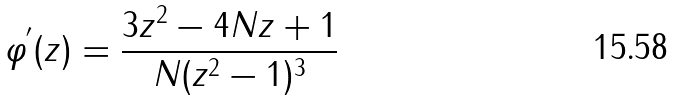<formula> <loc_0><loc_0><loc_500><loc_500>\varphi ^ { ^ { \prime } } ( z ) = \frac { 3 z ^ { 2 } - 4 N z + 1 } { N ( z ^ { 2 } - 1 ) ^ { 3 } }</formula> 